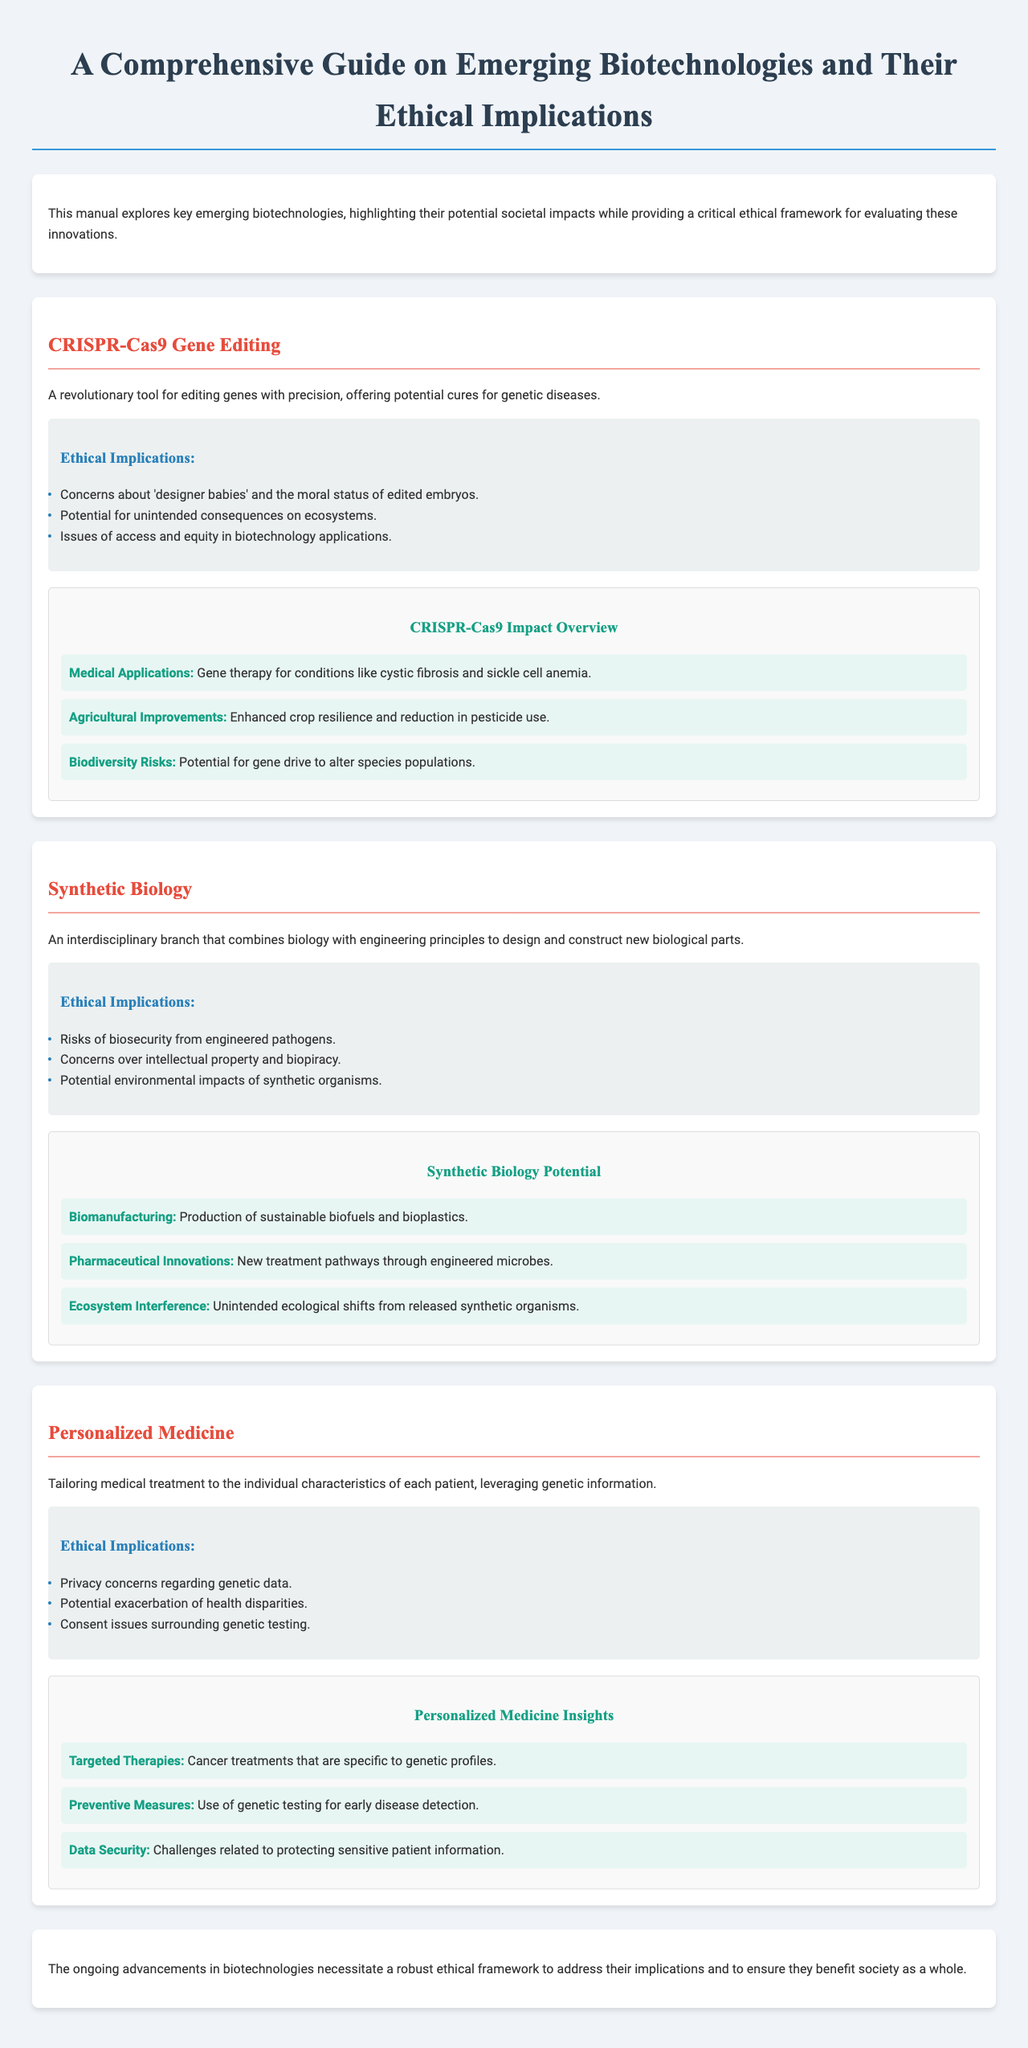What is the title of the manual? The title of the manual is stated at the top of the document, summarizing its content.
Answer: A Comprehensive Guide on Emerging Biotechnologies and Their Ethical Implications What technology is described as a "revolutionary tool for editing genes"? The document explicitly describes CRISPR-Cas9 as a revolutionary tool for gene editing.
Answer: CRISPR-Cas9 What are the primary ethical concerns associated with personalized medicine? The document lists the ethical implications specifically linked to personalized medicine, including privacy and health disparities.
Answer: Privacy concerns regarding genetic data Which biotechnology is associated with the production of sustainable biofuels? The infographic section provides information on the potential applications of synthetic biology, including sustainable biofuels.
Answer: Biomanufacturing What is one of the medical applications of CRISPR-Cas9? One of the benefits mentioned in the infographic related to CRISPR-Cas9 is its application in treating specific genetic diseases.
Answer: Gene therapy for conditions like cystic fibrosis and sickle cell anemia What is a risk mentioned in relation to synthetic biology? The ethical implications section highlights concerns regarding biosecurity due to engineered pathogens.
Answer: Risks of biosecurity from engineered pathogens How does the manual emphasize the importance of ethical frameworks? The conclusion of the document emphasizes the need for ethical frameworks as critical in evaluating biotechnological advancements.
Answer: A robust ethical framework How many biotechnologies are discussed in the document? The document provides detailed sections on three distinct biotechnologies, indicating their impacts and ethical concerns.
Answer: Three 